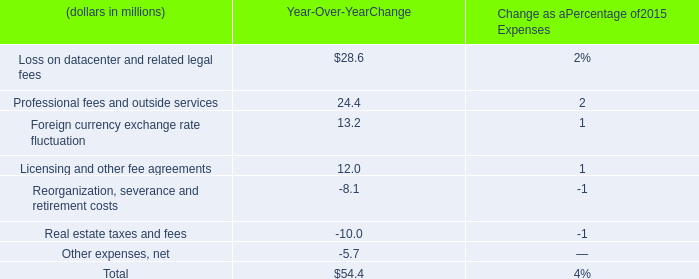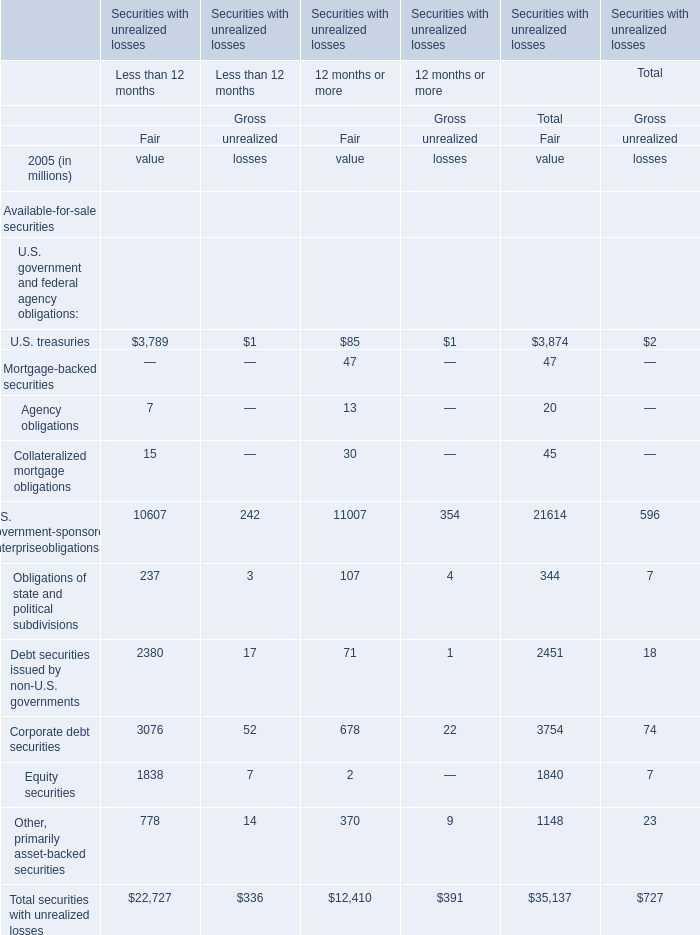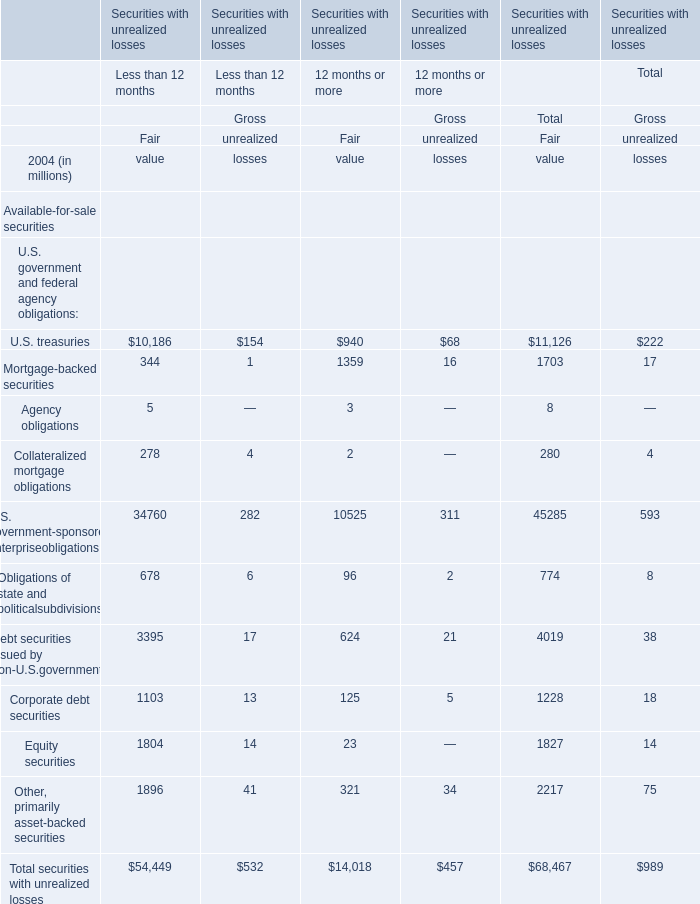What do all elements sum up for Fair of Less than 12 months , excluding U.S. treasuries and U.S. government-sponsored enterpriseobligations? (in million) 
Computations: (((((344 + 5) + 278) + 678) + 3395) + 1103)
Answer: 5803.0. 